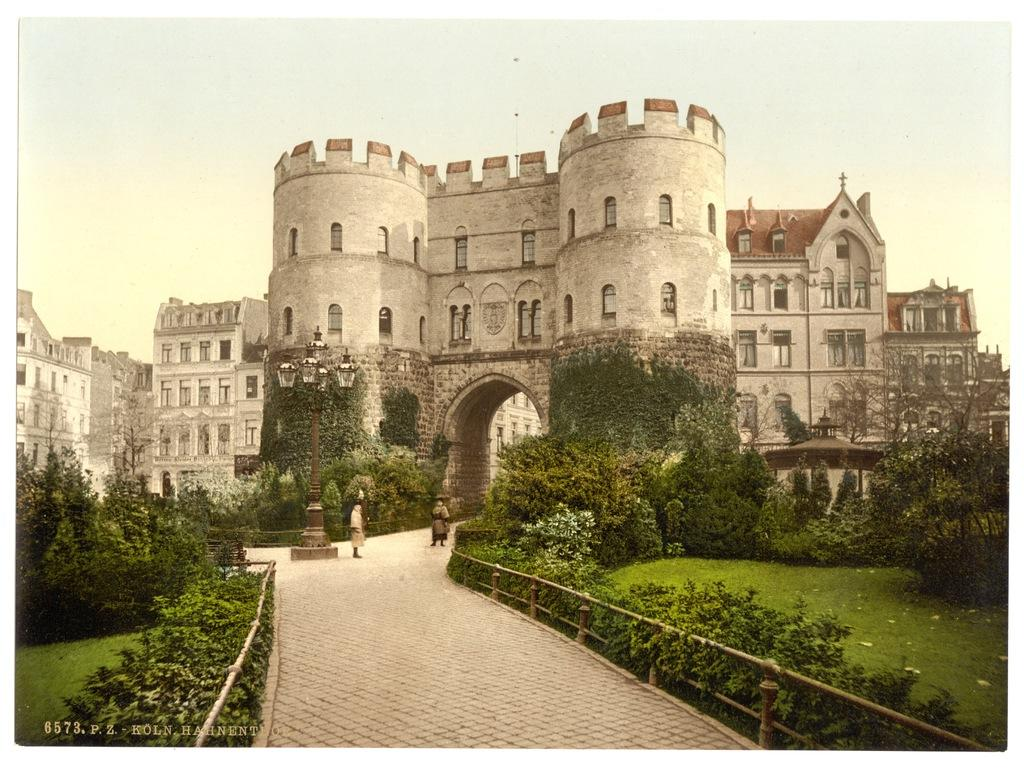What type of structures can be seen in the image? There are buildings in the image. What are the people in the image doing? The people in the image are on a pathway. What can be seen on either side of the pathway? There are plants and grass on either side of the pathway. What separates the pathway from the surrounding area? There is a fence on either side of the pathway. What type of ornament is hanging from the fire in the image? There is no fire or ornament present in the image. 